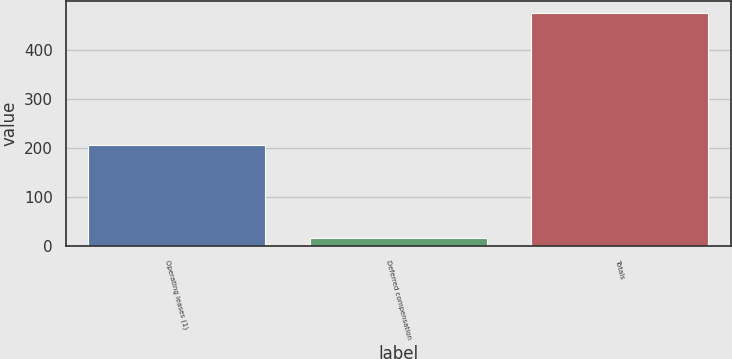Convert chart to OTSL. <chart><loc_0><loc_0><loc_500><loc_500><bar_chart><fcel>Operating leases (1)<fcel>Deferred compensation<fcel>Totals<nl><fcel>204.9<fcel>16.6<fcel>475.7<nl></chart> 